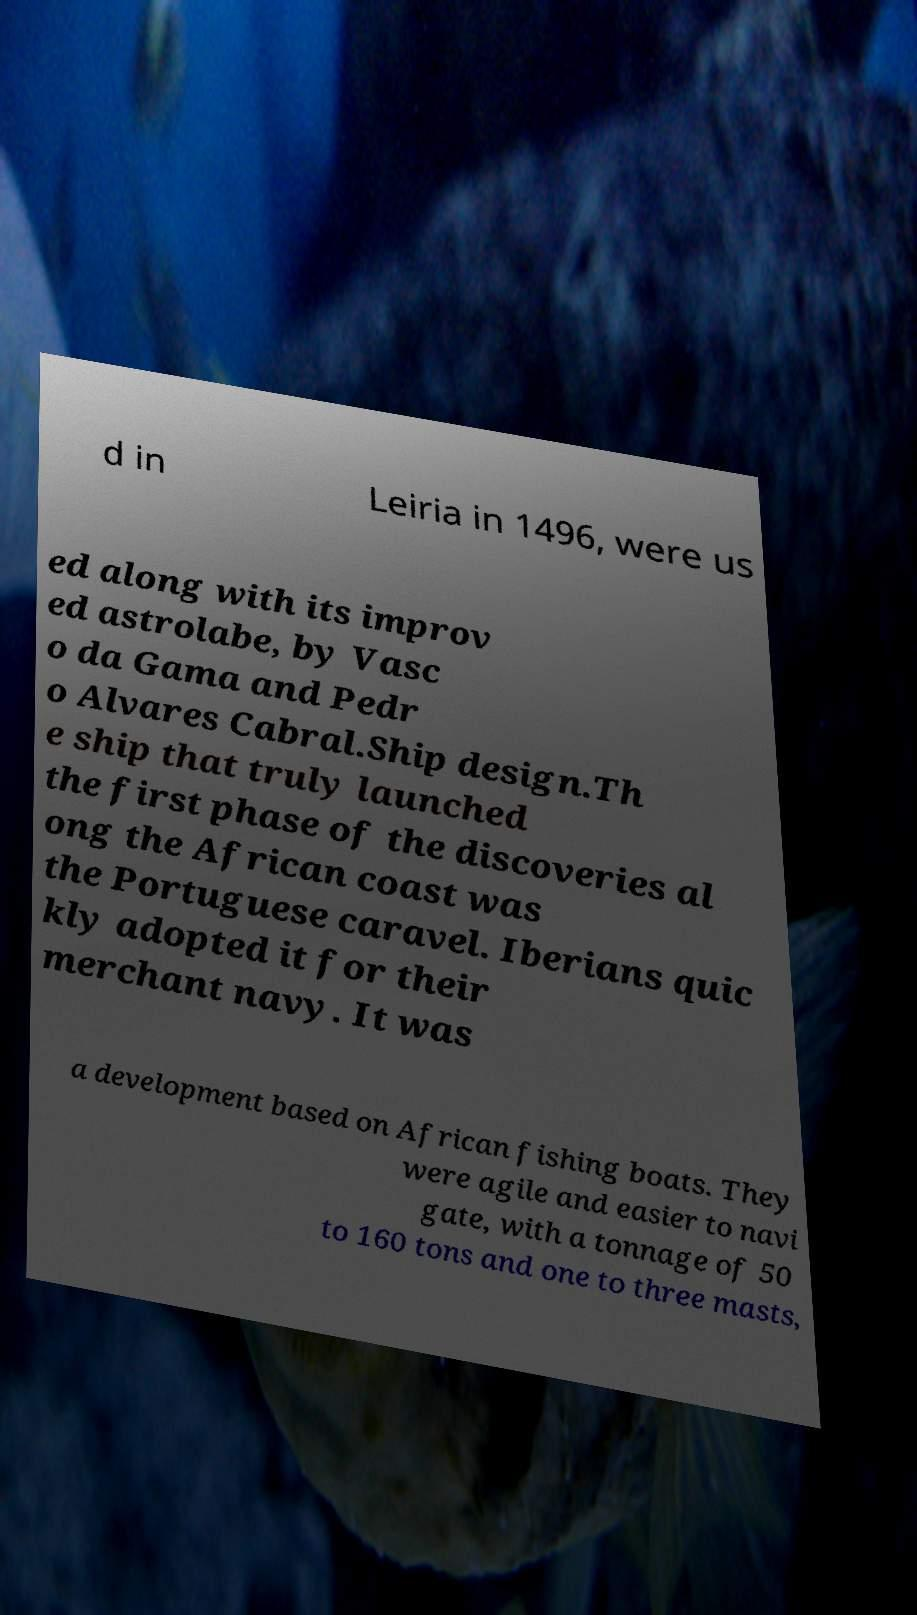There's text embedded in this image that I need extracted. Can you transcribe it verbatim? d in Leiria in 1496, were us ed along with its improv ed astrolabe, by Vasc o da Gama and Pedr o Alvares Cabral.Ship design.Th e ship that truly launched the first phase of the discoveries al ong the African coast was the Portuguese caravel. Iberians quic kly adopted it for their merchant navy. It was a development based on African fishing boats. They were agile and easier to navi gate, with a tonnage of 50 to 160 tons and one to three masts, 